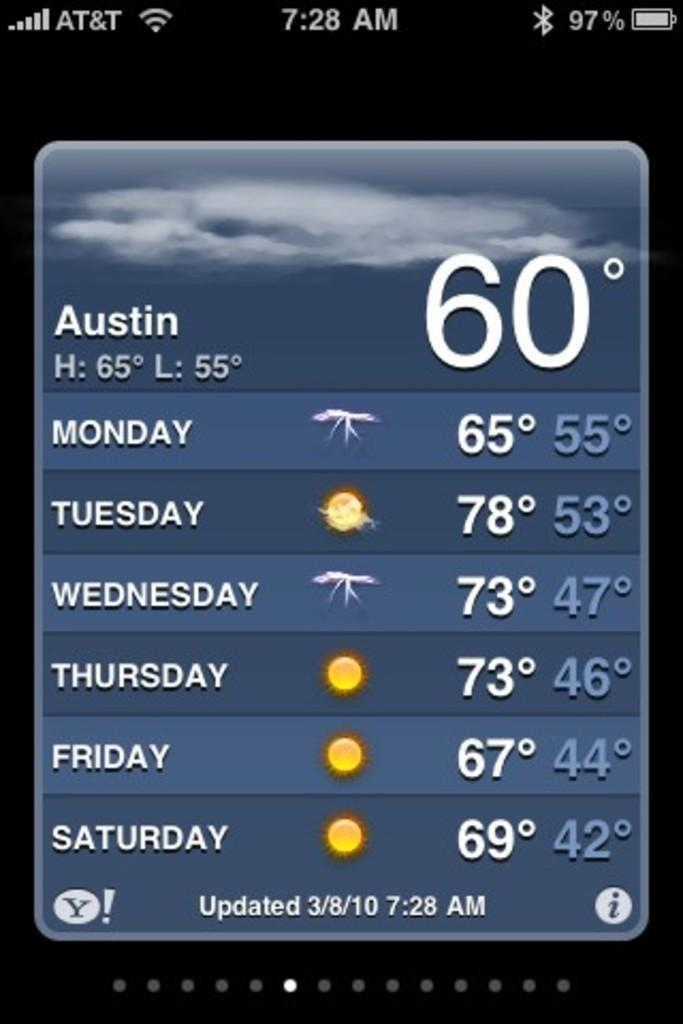<image>
Write a terse but informative summary of the picture. The temperature in Austin is currently 60 degrees, and the forecast for Monday through Saturday is shown. 